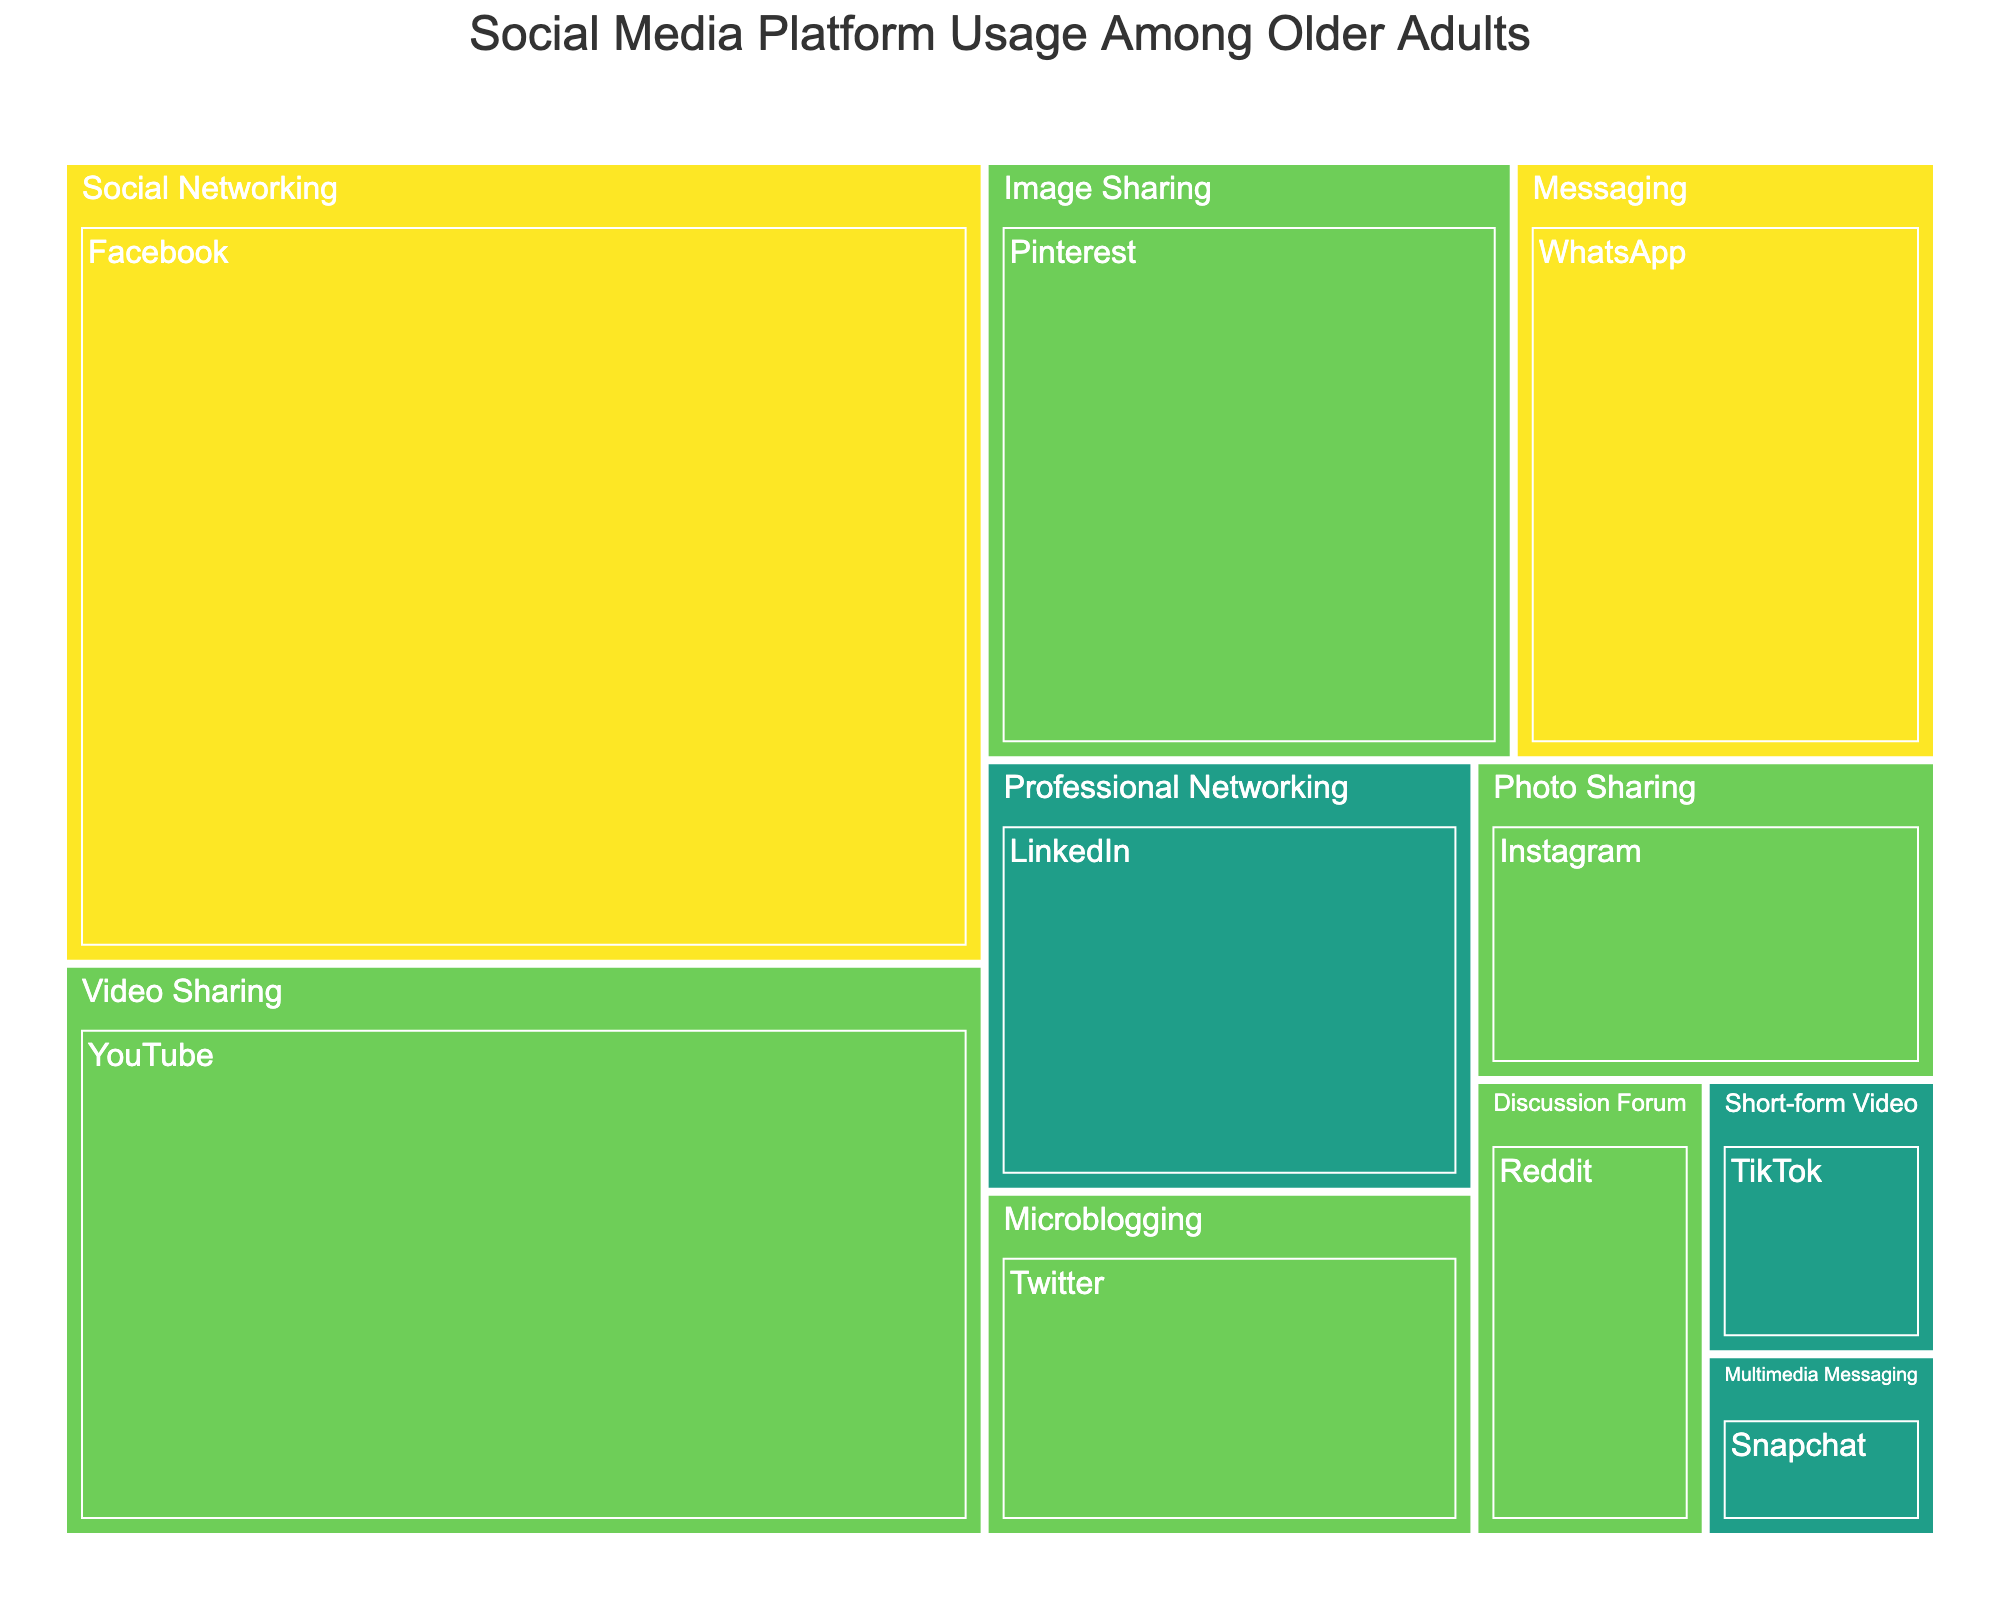what is the title of the figure? The title of the figure is displayed at the top and provides a summary of what the figure represents. By looking at the top of the figure, we can see that the title is "Social Media Platform Usage Among Older Adults".
Answer: Social Media Platform Usage Among Older Adults Which platform has the highest daily usage? Platforms are color-coded by frequency of use, and different colors represent daily, weekly, and monthly usage. The platform with the highest daily use is Facebook, as indicated by the largest area in the 'Daily' color category.
Answer: Facebook What is the total usage percentage for platforms used monthly? To find the total usage percentage for platforms used monthly, sum the usage percentages of the platforms listed under the 'Monthly' frequency. These platforms are LinkedIn (10), TikTok (3), and Snapchat (2). The total is 10 + 3 + 2.
Answer: 15 Which category has the most platforms included? Looking at the path structure of categories and platforms, count the number of platforms within each category. The 'Weekly' category includes YouTube, Pinterest, Twitter, Instagram, and Reddit, which is the most among all categories.
Answer: Weekly Compare the total usage between video-sharing and image-sharing platforms. Video-sharing and image-sharing platforms can be identified within their categories. Video-sharing includes YouTube (25) and TikTok (3), for a total of 28. Image-sharing includes Pinterest (15) and Instagram (7), for a total of 22. Compare these totals.
Answer: Video-sharing: 28, Image-sharing: 22 What is the percentage difference between the usage of WhatsApp and Twitter? The usage percentages for WhatsApp and Twitter are 12 and 8, respectively. The percentage difference is found by subtracting the smaller value from the larger one and then comparing to the original value: 12 - 8 = 4.
Answer: 4 Which platform has the smallest user base and how often is it used? By looking at the size of the areas and consulting the labels, Snapchat has the smallest user base with a usage percentage of 2. Additionally, it is used on a monthly basis as indicated by the color.
Answer: Snapchat, Monthly How many platforms are used weekly and what is their total usage percentage? Identify all platforms with weekly usage: YouTube, Pinterest, Twitter, Instagram, and Reddit. Sum their usage percentages. 25 + 15 + 8 + 7 + 5 = 60.
Answer: 5 platforms, 60 What is the ratio of daily users of Facebook to daily users of WhatsApp? The ratio can be calculated by dividing the user base of Facebook by the user base of WhatsApp. Facebook has 35 users and WhatsApp has 12 users. 35 / 12 = 2.92.
Answer: 2.92 Which category does LinkedIn fall under and what is its monthly usage percentage? LinkedIn falls under the category 'Professional Networking' and has a monthly usage of 10%, as represented by the labeled area in the figure.
Answer: Professional Networking, 10 